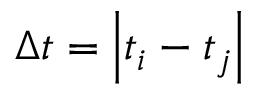<formula> <loc_0><loc_0><loc_500><loc_500>\Delta t = \left | t _ { i } - t _ { j } \right |</formula> 